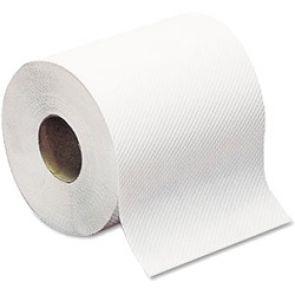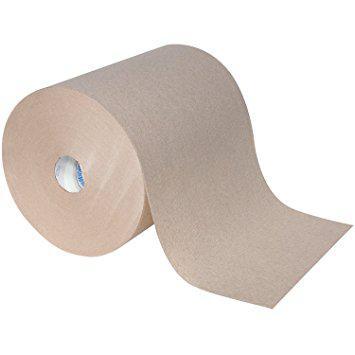The first image is the image on the left, the second image is the image on the right. Given the left and right images, does the statement "The right-hand roll is noticeably browner and darker in color." hold true? Answer yes or no. Yes. 